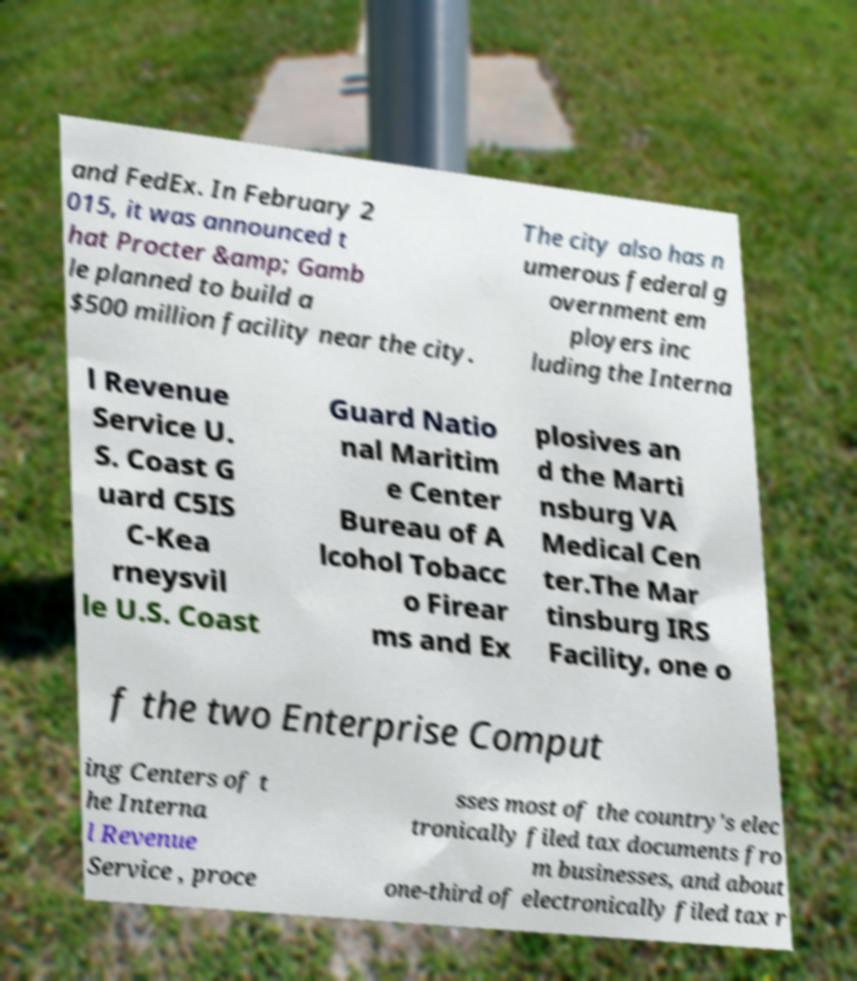Could you extract and type out the text from this image? and FedEx. In February 2 015, it was announced t hat Procter &amp; Gamb le planned to build a $500 million facility near the city. The city also has n umerous federal g overnment em ployers inc luding the Interna l Revenue Service U. S. Coast G uard C5IS C-Kea rneysvil le U.S. Coast Guard Natio nal Maritim e Center Bureau of A lcohol Tobacc o Firear ms and Ex plosives an d the Marti nsburg VA Medical Cen ter.The Mar tinsburg IRS Facility, one o f the two Enterprise Comput ing Centers of t he Interna l Revenue Service , proce sses most of the country's elec tronically filed tax documents fro m businesses, and about one-third of electronically filed tax r 